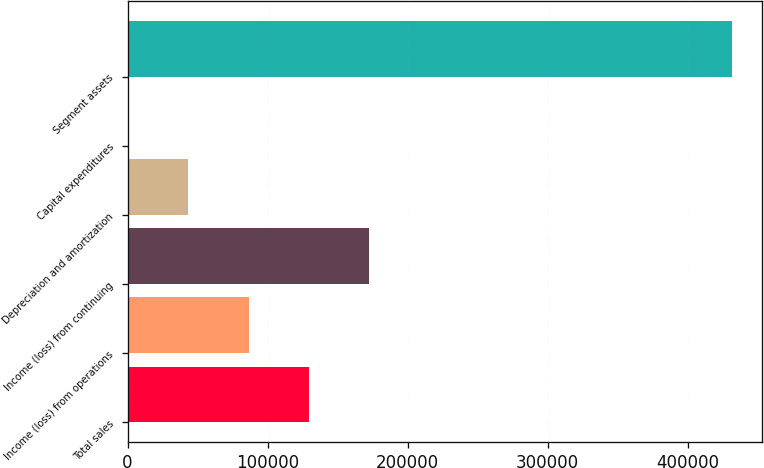Convert chart to OTSL. <chart><loc_0><loc_0><loc_500><loc_500><bar_chart><fcel>Total sales<fcel>Income (loss) from operations<fcel>Income (loss) from continuing<fcel>Depreciation and amortization<fcel>Capital expenditures<fcel>Segment assets<nl><fcel>129723<fcel>86606.6<fcel>172840<fcel>43489.8<fcel>373<fcel>431541<nl></chart> 